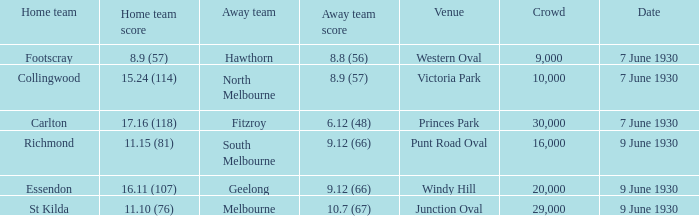7 (67)? 29000.0. 